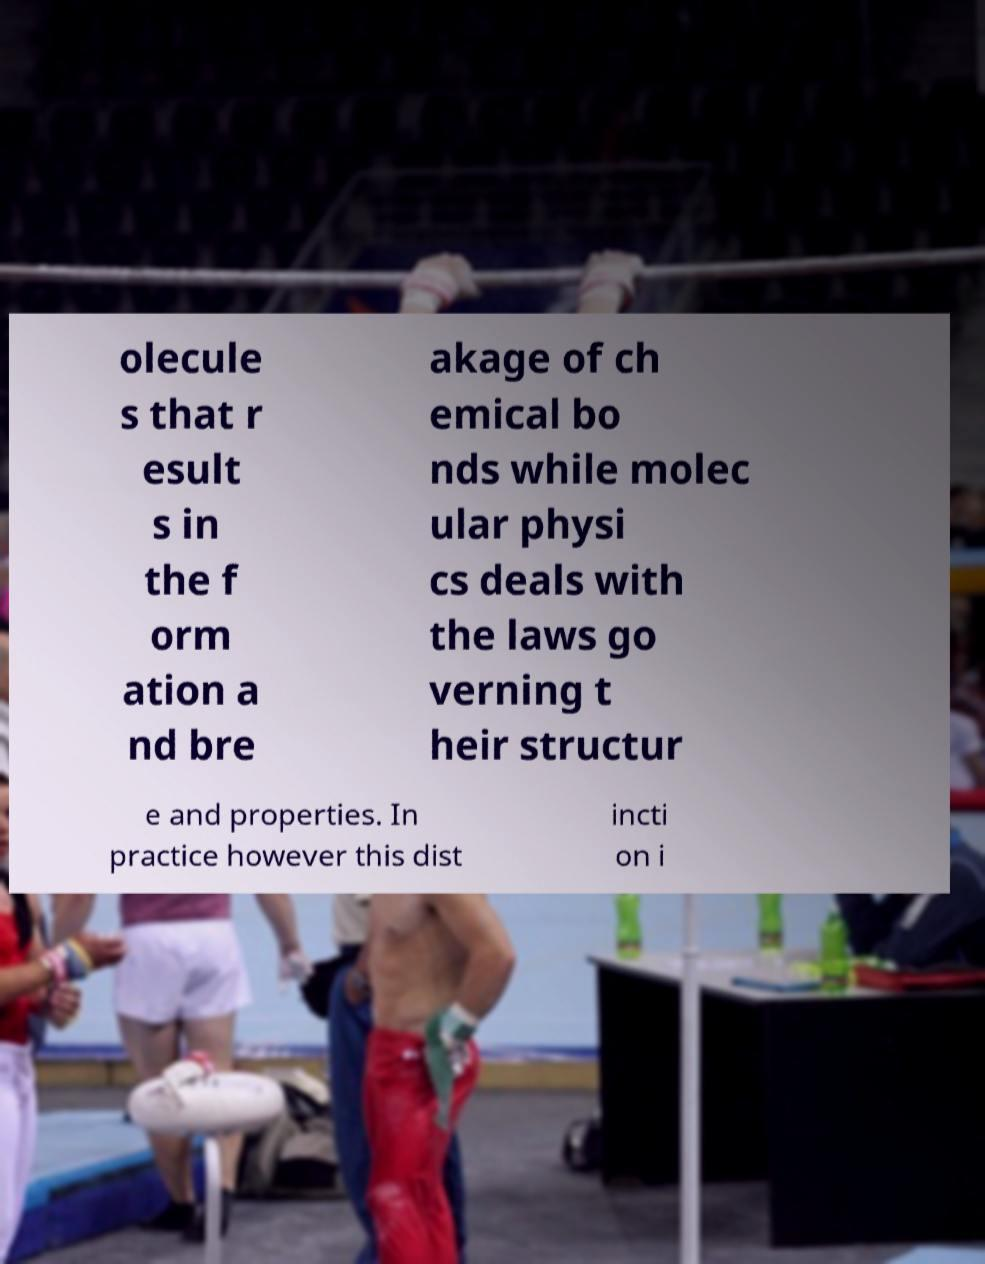What messages or text are displayed in this image? I need them in a readable, typed format. olecule s that r esult s in the f orm ation a nd bre akage of ch emical bo nds while molec ular physi cs deals with the laws go verning t heir structur e and properties. In practice however this dist incti on i 